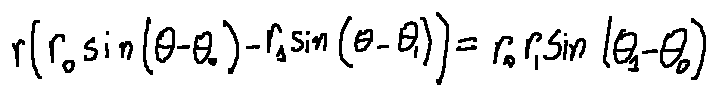<formula> <loc_0><loc_0><loc_500><loc_500>r ( r _ { 0 } \sin ( \theta - \theta _ { 0 } ) - r _ { 1 } \sin ( \theta - \theta _ { 1 } ) ) = r _ { 0 } r _ { 1 } \sin ( \theta _ { 1 } - \theta _ { 0 } )</formula> 